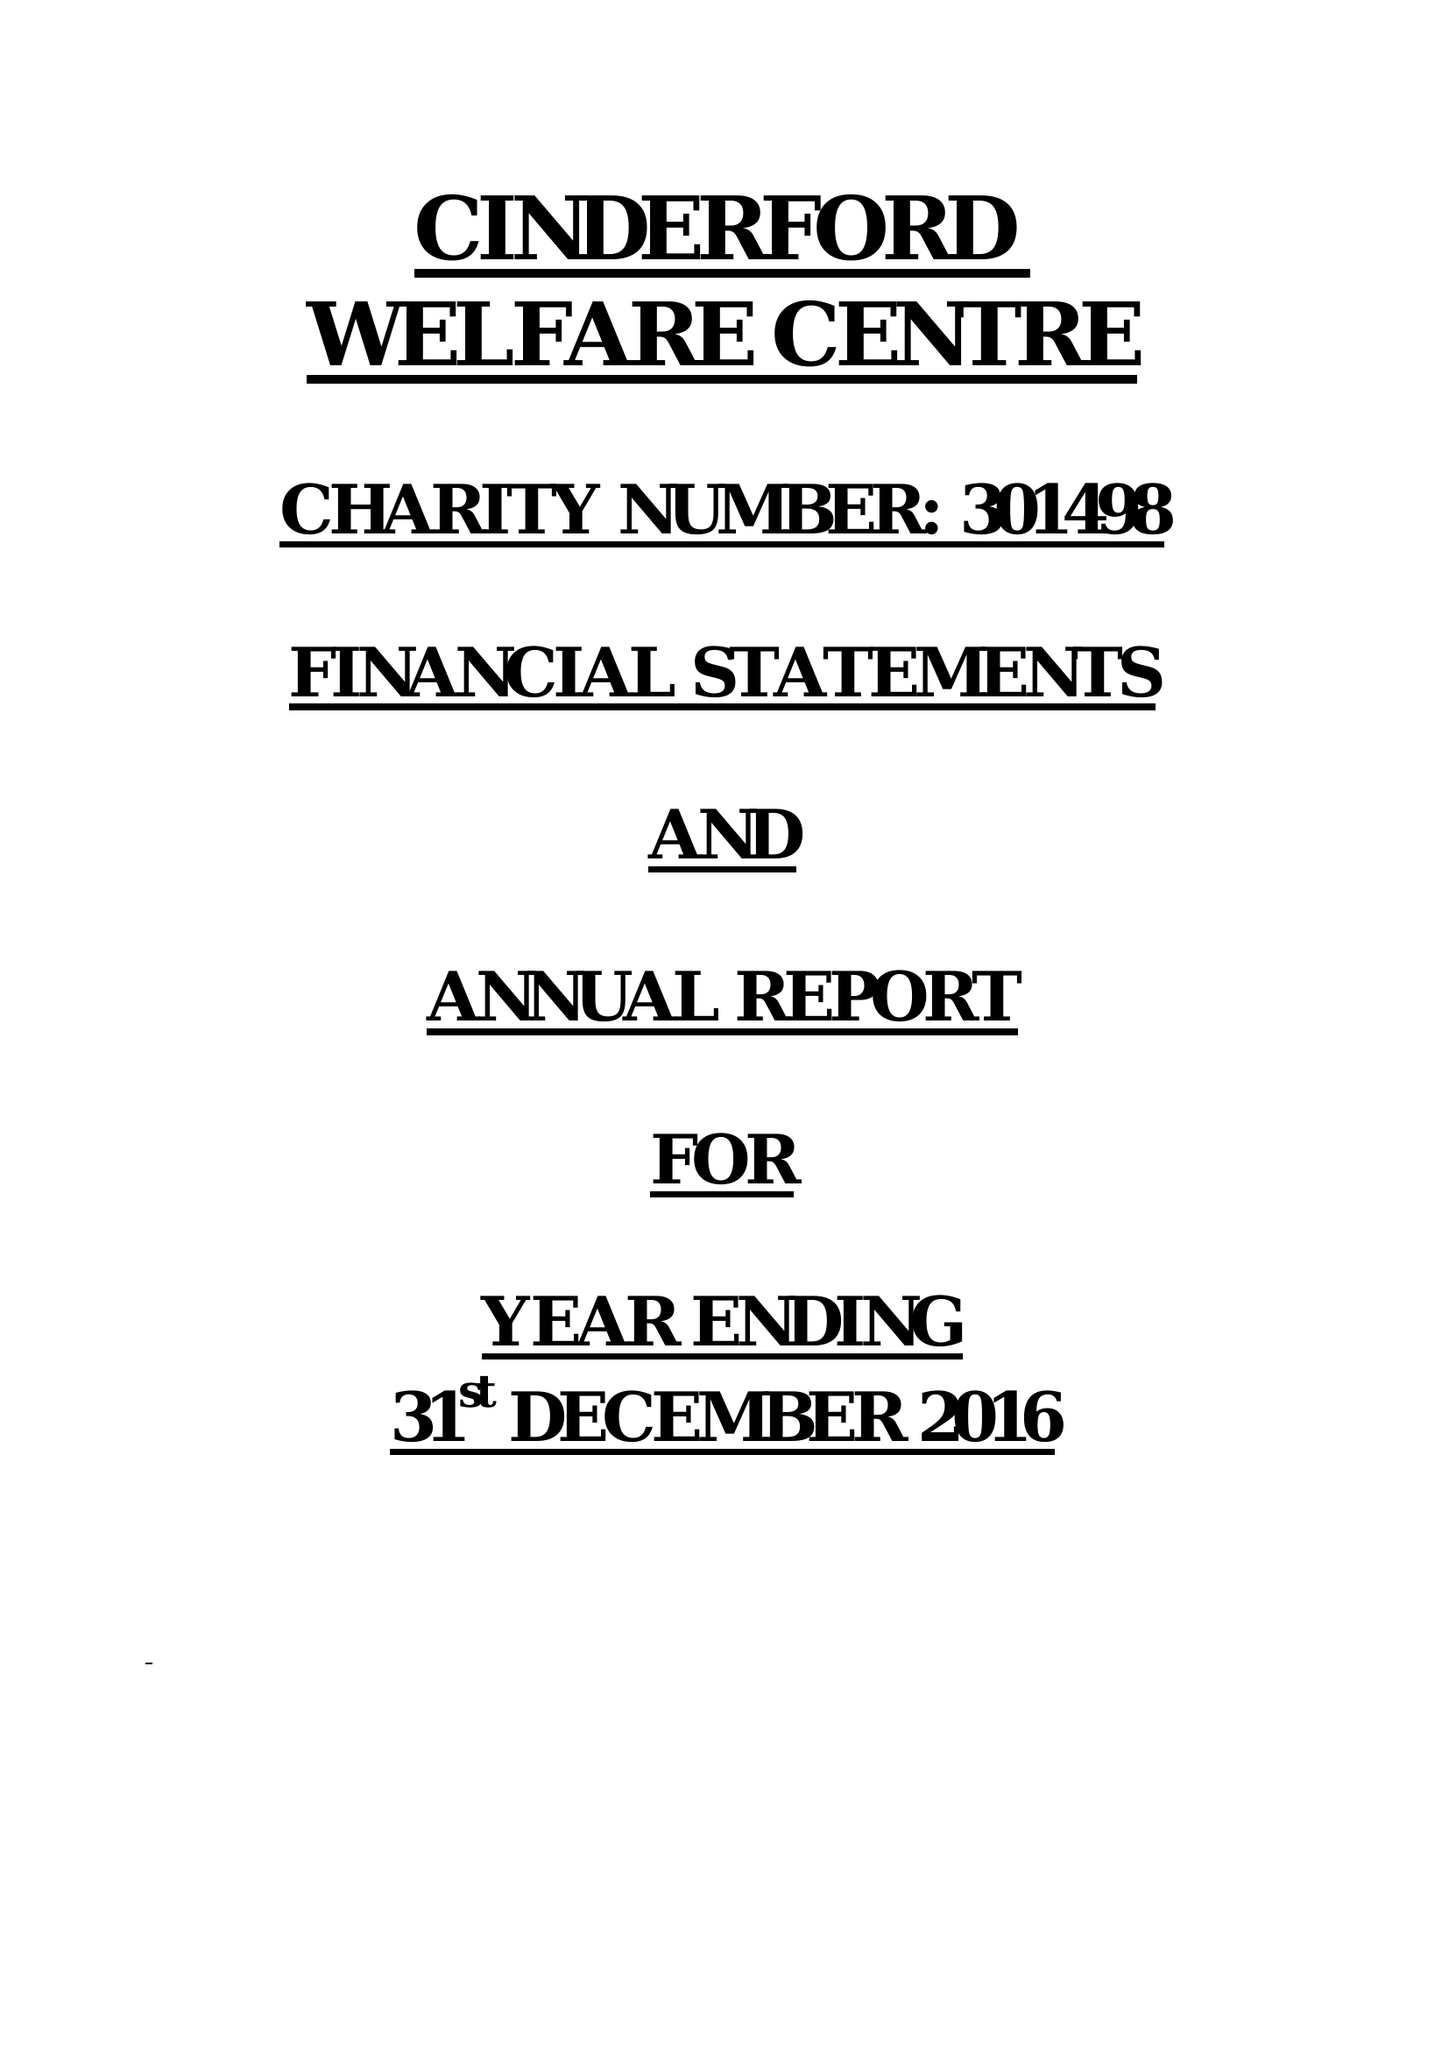What is the value for the address__street_line?
Answer the question using a single word or phrase. WESLEY ROAD 